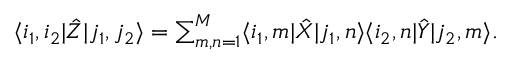Convert formula to latex. <formula><loc_0><loc_0><loc_500><loc_500>\langle i _ { 1 } , i _ { 2 } | \hat { Z } | j _ { 1 } , j _ { 2 } \rangle = \sum _ { m , n = 1 } ^ { M } \langle i _ { 1 } , m | \hat { X } | j _ { 1 } , n \rangle \langle i _ { 2 } , n | \hat { Y } | j _ { 2 } , m \rangle .</formula> 